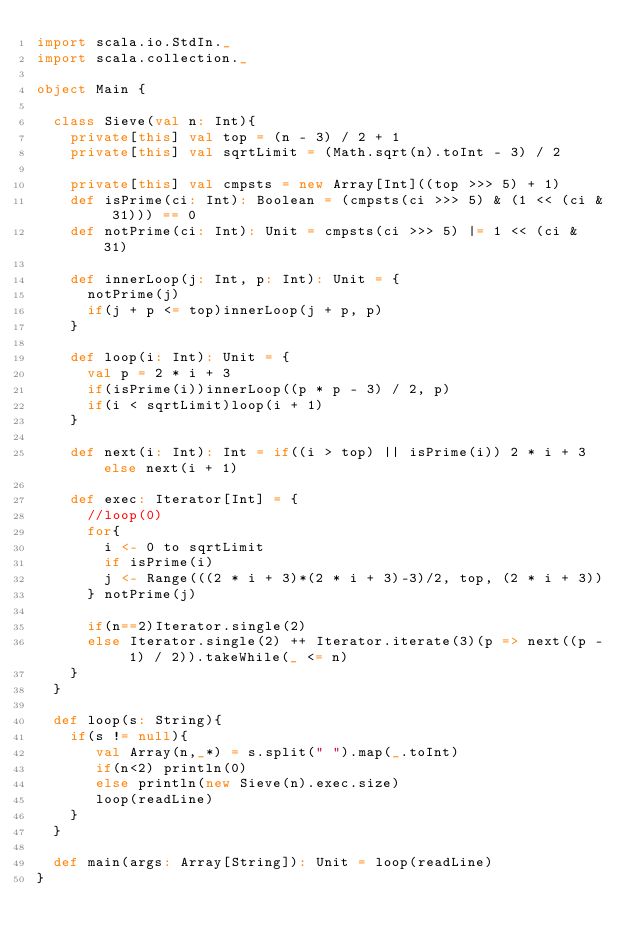<code> <loc_0><loc_0><loc_500><loc_500><_Scala_>import scala.io.StdIn._
import scala.collection._

object Main {

  class Sieve(val n: Int){
    private[this] val top = (n - 3) / 2 + 1
    private[this] val sqrtLimit = (Math.sqrt(n).toInt - 3) / 2

    private[this] val cmpsts = new Array[Int]((top >>> 5) + 1)
    def isPrime(ci: Int): Boolean = (cmpsts(ci >>> 5) & (1 << (ci & 31))) == 0
    def notPrime(ci: Int): Unit = cmpsts(ci >>> 5) |= 1 << (ci & 31)

    def innerLoop(j: Int, p: Int): Unit = {
      notPrime(j)
      if(j + p <= top)innerLoop(j + p, p)
    }

    def loop(i: Int): Unit = {
      val p = 2 * i + 3
      if(isPrime(i))innerLoop((p * p - 3) / 2, p)
      if(i < sqrtLimit)loop(i + 1)
    }

    def next(i: Int): Int = if((i > top) || isPrime(i)) 2 * i + 3 else next(i + 1)

    def exec: Iterator[Int] = {
      //loop(0)
      for{
        i <- 0 to sqrtLimit
        if isPrime(i)
        j <- Range(((2 * i + 3)*(2 * i + 3)-3)/2, top, (2 * i + 3))
      } notPrime(j)

      if(n==2)Iterator.single(2)
      else Iterator.single(2) ++ Iterator.iterate(3)(p => next((p - 1) / 2)).takeWhile(_ <= n)
    }
  }

  def loop(s: String){
    if(s != null){
       val Array(n,_*) = s.split(" ").map(_.toInt)
       if(n<2) println(0)
       else println(new Sieve(n).exec.size)
       loop(readLine)
    }
  }

  def main(args: Array[String]): Unit = loop(readLine)
}</code> 